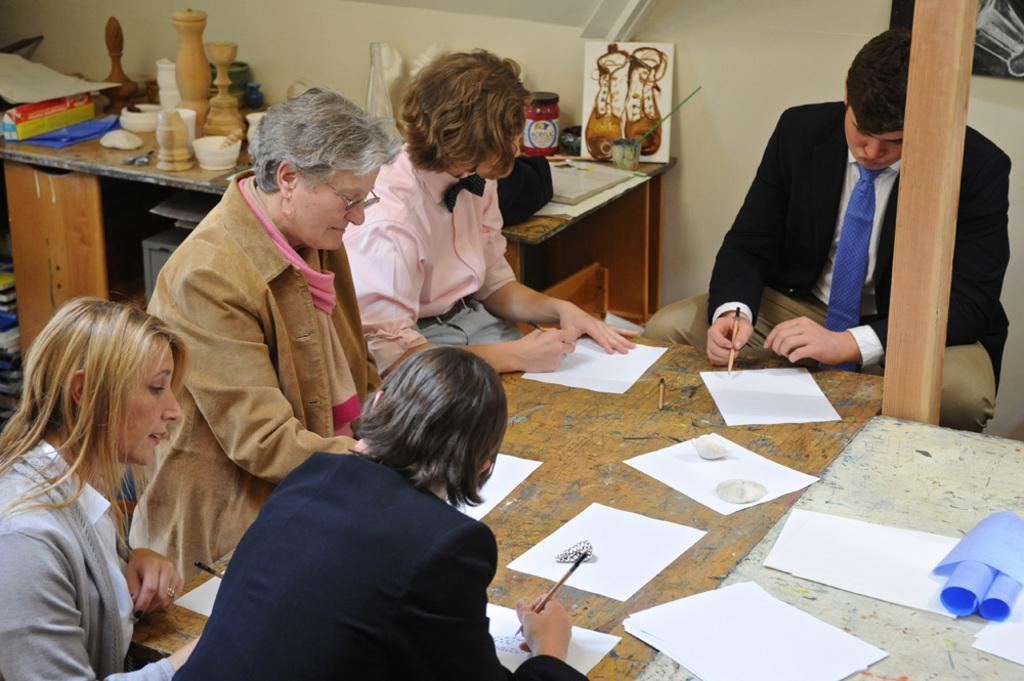Can you describe this image briefly? In this image, we can see people sitting and holding pencils in their hands and there are pencils and papers placed on the table. In the background, we can see a bowl, jar and some packets which are on the table. 